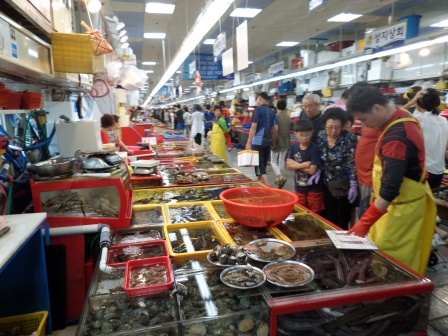What's happening in the scene? The image captures a dynamic and lively scene at an indoor seafood market. Vendors, distinguishable by their bright yellow and red aprons, are behind large tanks filled with various types of seafood, arranged meticulously in organized rows. Shoppers are seen navigating the market, intently examining the fresh seafood on display. The high ceilings with hanging lights create a warm ambiance, illuminating the bustling market. Though not readable, signs hang from the ceiling and adorn the walls, indicating various stalls and sections. Overall, the scene showcases a typical busy day at a seafood market, characterized by the energetic interactions between vendors and customers and the vivid display of seafood. 